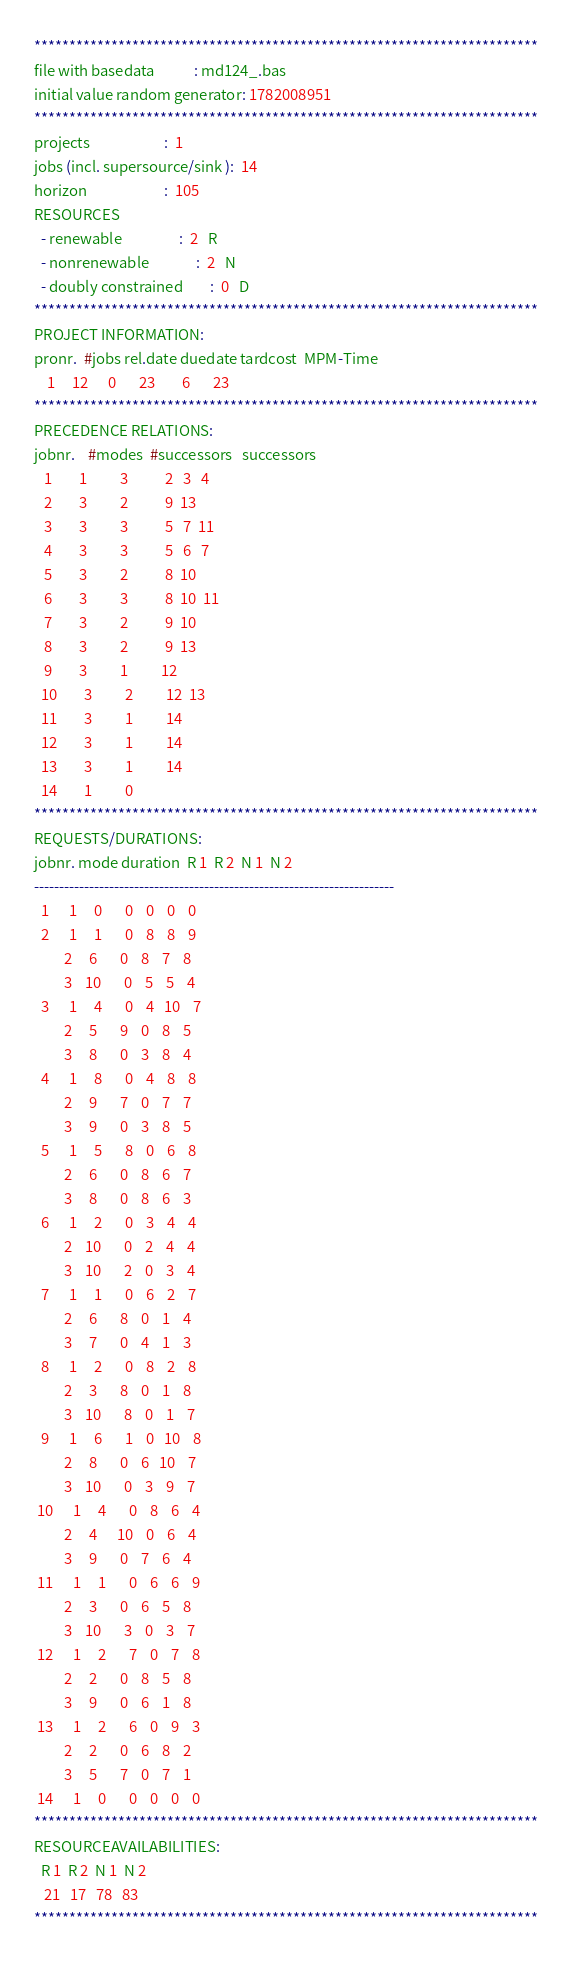Convert code to text. <code><loc_0><loc_0><loc_500><loc_500><_ObjectiveC_>************************************************************************
file with basedata            : md124_.bas
initial value random generator: 1782008951
************************************************************************
projects                      :  1
jobs (incl. supersource/sink ):  14
horizon                       :  105
RESOURCES
  - renewable                 :  2   R
  - nonrenewable              :  2   N
  - doubly constrained        :  0   D
************************************************************************
PROJECT INFORMATION:
pronr.  #jobs rel.date duedate tardcost  MPM-Time
    1     12      0       23        6       23
************************************************************************
PRECEDENCE RELATIONS:
jobnr.    #modes  #successors   successors
   1        1          3           2   3   4
   2        3          2           9  13
   3        3          3           5   7  11
   4        3          3           5   6   7
   5        3          2           8  10
   6        3          3           8  10  11
   7        3          2           9  10
   8        3          2           9  13
   9        3          1          12
  10        3          2          12  13
  11        3          1          14
  12        3          1          14
  13        3          1          14
  14        1          0        
************************************************************************
REQUESTS/DURATIONS:
jobnr. mode duration  R 1  R 2  N 1  N 2
------------------------------------------------------------------------
  1      1     0       0    0    0    0
  2      1     1       0    8    8    9
         2     6       0    8    7    8
         3    10       0    5    5    4
  3      1     4       0    4   10    7
         2     5       9    0    8    5
         3     8       0    3    8    4
  4      1     8       0    4    8    8
         2     9       7    0    7    7
         3     9       0    3    8    5
  5      1     5       8    0    6    8
         2     6       0    8    6    7
         3     8       0    8    6    3
  6      1     2       0    3    4    4
         2    10       0    2    4    4
         3    10       2    0    3    4
  7      1     1       0    6    2    7
         2     6       8    0    1    4
         3     7       0    4    1    3
  8      1     2       0    8    2    8
         2     3       8    0    1    8
         3    10       8    0    1    7
  9      1     6       1    0   10    8
         2     8       0    6   10    7
         3    10       0    3    9    7
 10      1     4       0    8    6    4
         2     4      10    0    6    4
         3     9       0    7    6    4
 11      1     1       0    6    6    9
         2     3       0    6    5    8
         3    10       3    0    3    7
 12      1     2       7    0    7    8
         2     2       0    8    5    8
         3     9       0    6    1    8
 13      1     2       6    0    9    3
         2     2       0    6    8    2
         3     5       7    0    7    1
 14      1     0       0    0    0    0
************************************************************************
RESOURCEAVAILABILITIES:
  R 1  R 2  N 1  N 2
   21   17   78   83
************************************************************************
</code> 